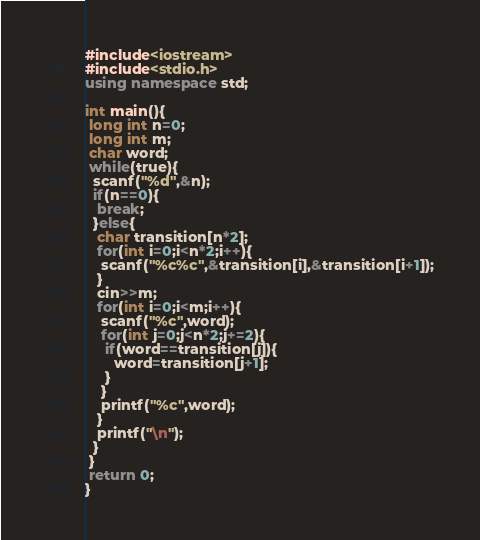Convert code to text. <code><loc_0><loc_0><loc_500><loc_500><_C++_>#include<iostream>
#include<stdio.h>
using namespace std;
  
int main(){
 long int n=0;
 long int m;
 char word;
 while(true){
  scanf("%d",&n);
  if(n==0){
   break;
  }else{
   char transition[n*2];
   for(int i=0;i<n*2;i++){
    scanf("%c%c",&transition[i],&transition[i+1]);
   }
   cin>>m;
   for(int i=0;i<m;i++){
    scanf("%c",word);
    for(int j=0;j<n*2;j+=2){
     if(word==transition[j]){
       word=transition[j+1];
     }
    }
    printf("%c",word);
   }
   printf("\n");
  }
 }
 return 0;
}</code> 